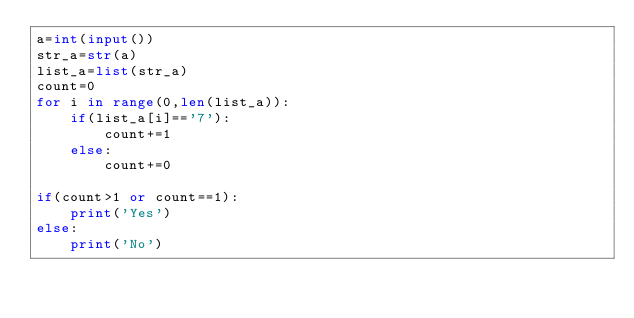Convert code to text. <code><loc_0><loc_0><loc_500><loc_500><_Python_>a=int(input())
str_a=str(a)
list_a=list(str_a)
count=0
for i in range(0,len(list_a)):
	if(list_a[i]=='7'):
		count+=1
	else:
		count+=0
	
if(count>1 or count==1):
	print('Yes')
else:
	print('No')
</code> 